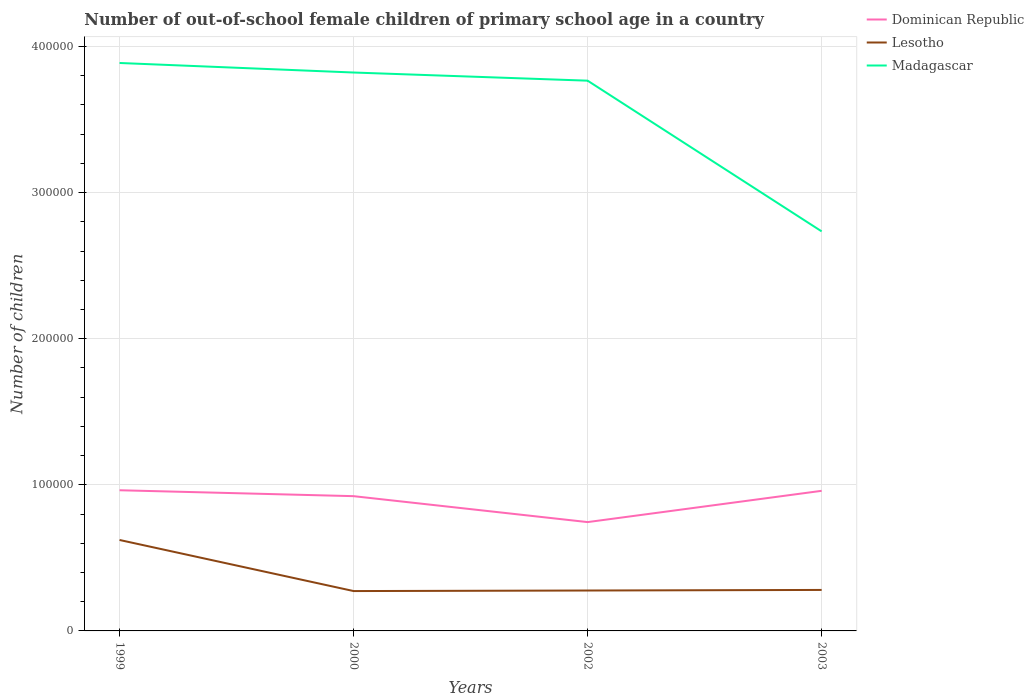Does the line corresponding to Madagascar intersect with the line corresponding to Dominican Republic?
Provide a succinct answer. No. Is the number of lines equal to the number of legend labels?
Provide a succinct answer. Yes. Across all years, what is the maximum number of out-of-school female children in Dominican Republic?
Ensure brevity in your answer.  7.45e+04. In which year was the number of out-of-school female children in Madagascar maximum?
Make the answer very short. 2003. What is the total number of out-of-school female children in Dominican Republic in the graph?
Ensure brevity in your answer.  1.78e+04. What is the difference between the highest and the second highest number of out-of-school female children in Madagascar?
Give a very brief answer. 1.15e+05. Is the number of out-of-school female children in Lesotho strictly greater than the number of out-of-school female children in Madagascar over the years?
Offer a terse response. Yes. How many years are there in the graph?
Your answer should be very brief. 4. What is the difference between two consecutive major ticks on the Y-axis?
Give a very brief answer. 1.00e+05. Are the values on the major ticks of Y-axis written in scientific E-notation?
Your answer should be very brief. No. How many legend labels are there?
Ensure brevity in your answer.  3. What is the title of the graph?
Give a very brief answer. Number of out-of-school female children of primary school age in a country. What is the label or title of the X-axis?
Provide a succinct answer. Years. What is the label or title of the Y-axis?
Keep it short and to the point. Number of children. What is the Number of children of Dominican Republic in 1999?
Provide a short and direct response. 9.63e+04. What is the Number of children in Lesotho in 1999?
Make the answer very short. 6.22e+04. What is the Number of children of Madagascar in 1999?
Ensure brevity in your answer.  3.89e+05. What is the Number of children in Dominican Republic in 2000?
Provide a short and direct response. 9.22e+04. What is the Number of children in Lesotho in 2000?
Your answer should be compact. 2.73e+04. What is the Number of children in Madagascar in 2000?
Give a very brief answer. 3.82e+05. What is the Number of children of Dominican Republic in 2002?
Offer a terse response. 7.45e+04. What is the Number of children of Lesotho in 2002?
Your answer should be very brief. 2.77e+04. What is the Number of children of Madagascar in 2002?
Your answer should be very brief. 3.77e+05. What is the Number of children of Dominican Republic in 2003?
Your answer should be very brief. 9.59e+04. What is the Number of children of Lesotho in 2003?
Keep it short and to the point. 2.81e+04. What is the Number of children of Madagascar in 2003?
Keep it short and to the point. 2.73e+05. Across all years, what is the maximum Number of children in Dominican Republic?
Offer a terse response. 9.63e+04. Across all years, what is the maximum Number of children in Lesotho?
Your answer should be compact. 6.22e+04. Across all years, what is the maximum Number of children of Madagascar?
Provide a short and direct response. 3.89e+05. Across all years, what is the minimum Number of children in Dominican Republic?
Give a very brief answer. 7.45e+04. Across all years, what is the minimum Number of children of Lesotho?
Offer a very short reply. 2.73e+04. Across all years, what is the minimum Number of children of Madagascar?
Offer a terse response. 2.73e+05. What is the total Number of children in Dominican Republic in the graph?
Keep it short and to the point. 3.59e+05. What is the total Number of children in Lesotho in the graph?
Provide a succinct answer. 1.45e+05. What is the total Number of children of Madagascar in the graph?
Your response must be concise. 1.42e+06. What is the difference between the Number of children in Dominican Republic in 1999 and that in 2000?
Keep it short and to the point. 4044. What is the difference between the Number of children in Lesotho in 1999 and that in 2000?
Offer a terse response. 3.50e+04. What is the difference between the Number of children of Madagascar in 1999 and that in 2000?
Offer a terse response. 6523. What is the difference between the Number of children in Dominican Republic in 1999 and that in 2002?
Make the answer very short. 2.18e+04. What is the difference between the Number of children of Lesotho in 1999 and that in 2002?
Keep it short and to the point. 3.46e+04. What is the difference between the Number of children of Madagascar in 1999 and that in 2002?
Make the answer very short. 1.21e+04. What is the difference between the Number of children in Dominican Republic in 1999 and that in 2003?
Ensure brevity in your answer.  392. What is the difference between the Number of children of Lesotho in 1999 and that in 2003?
Ensure brevity in your answer.  3.42e+04. What is the difference between the Number of children in Madagascar in 1999 and that in 2003?
Offer a very short reply. 1.15e+05. What is the difference between the Number of children in Dominican Republic in 2000 and that in 2002?
Offer a terse response. 1.78e+04. What is the difference between the Number of children in Lesotho in 2000 and that in 2002?
Your answer should be compact. -375. What is the difference between the Number of children in Madagascar in 2000 and that in 2002?
Keep it short and to the point. 5584. What is the difference between the Number of children of Dominican Republic in 2000 and that in 2003?
Provide a succinct answer. -3652. What is the difference between the Number of children of Lesotho in 2000 and that in 2003?
Your answer should be compact. -769. What is the difference between the Number of children in Madagascar in 2000 and that in 2003?
Provide a short and direct response. 1.09e+05. What is the difference between the Number of children in Dominican Republic in 2002 and that in 2003?
Provide a succinct answer. -2.14e+04. What is the difference between the Number of children in Lesotho in 2002 and that in 2003?
Your answer should be compact. -394. What is the difference between the Number of children in Madagascar in 2002 and that in 2003?
Your answer should be very brief. 1.03e+05. What is the difference between the Number of children in Dominican Republic in 1999 and the Number of children in Lesotho in 2000?
Your answer should be compact. 6.90e+04. What is the difference between the Number of children in Dominican Republic in 1999 and the Number of children in Madagascar in 2000?
Your answer should be compact. -2.86e+05. What is the difference between the Number of children in Lesotho in 1999 and the Number of children in Madagascar in 2000?
Your response must be concise. -3.20e+05. What is the difference between the Number of children in Dominican Republic in 1999 and the Number of children in Lesotho in 2002?
Provide a succinct answer. 6.86e+04. What is the difference between the Number of children of Dominican Republic in 1999 and the Number of children of Madagascar in 2002?
Provide a short and direct response. -2.80e+05. What is the difference between the Number of children of Lesotho in 1999 and the Number of children of Madagascar in 2002?
Your response must be concise. -3.14e+05. What is the difference between the Number of children of Dominican Republic in 1999 and the Number of children of Lesotho in 2003?
Provide a succinct answer. 6.82e+04. What is the difference between the Number of children of Dominican Republic in 1999 and the Number of children of Madagascar in 2003?
Offer a terse response. -1.77e+05. What is the difference between the Number of children in Lesotho in 1999 and the Number of children in Madagascar in 2003?
Your response must be concise. -2.11e+05. What is the difference between the Number of children in Dominican Republic in 2000 and the Number of children in Lesotho in 2002?
Your answer should be compact. 6.46e+04. What is the difference between the Number of children in Dominican Republic in 2000 and the Number of children in Madagascar in 2002?
Your response must be concise. -2.84e+05. What is the difference between the Number of children in Lesotho in 2000 and the Number of children in Madagascar in 2002?
Make the answer very short. -3.49e+05. What is the difference between the Number of children of Dominican Republic in 2000 and the Number of children of Lesotho in 2003?
Your answer should be very brief. 6.42e+04. What is the difference between the Number of children in Dominican Republic in 2000 and the Number of children in Madagascar in 2003?
Provide a succinct answer. -1.81e+05. What is the difference between the Number of children in Lesotho in 2000 and the Number of children in Madagascar in 2003?
Offer a terse response. -2.46e+05. What is the difference between the Number of children in Dominican Republic in 2002 and the Number of children in Lesotho in 2003?
Ensure brevity in your answer.  4.64e+04. What is the difference between the Number of children in Dominican Republic in 2002 and the Number of children in Madagascar in 2003?
Your answer should be very brief. -1.99e+05. What is the difference between the Number of children in Lesotho in 2002 and the Number of children in Madagascar in 2003?
Offer a terse response. -2.46e+05. What is the average Number of children of Dominican Republic per year?
Make the answer very short. 8.97e+04. What is the average Number of children in Lesotho per year?
Your answer should be compact. 3.63e+04. What is the average Number of children in Madagascar per year?
Offer a terse response. 3.55e+05. In the year 1999, what is the difference between the Number of children of Dominican Republic and Number of children of Lesotho?
Make the answer very short. 3.40e+04. In the year 1999, what is the difference between the Number of children of Dominican Republic and Number of children of Madagascar?
Offer a very short reply. -2.92e+05. In the year 1999, what is the difference between the Number of children of Lesotho and Number of children of Madagascar?
Provide a succinct answer. -3.26e+05. In the year 2000, what is the difference between the Number of children in Dominican Republic and Number of children in Lesotho?
Provide a succinct answer. 6.50e+04. In the year 2000, what is the difference between the Number of children in Dominican Republic and Number of children in Madagascar?
Offer a terse response. -2.90e+05. In the year 2000, what is the difference between the Number of children of Lesotho and Number of children of Madagascar?
Your response must be concise. -3.55e+05. In the year 2002, what is the difference between the Number of children of Dominican Republic and Number of children of Lesotho?
Make the answer very short. 4.68e+04. In the year 2002, what is the difference between the Number of children of Dominican Republic and Number of children of Madagascar?
Provide a short and direct response. -3.02e+05. In the year 2002, what is the difference between the Number of children of Lesotho and Number of children of Madagascar?
Provide a succinct answer. -3.49e+05. In the year 2003, what is the difference between the Number of children in Dominican Republic and Number of children in Lesotho?
Provide a succinct answer. 6.78e+04. In the year 2003, what is the difference between the Number of children in Dominican Republic and Number of children in Madagascar?
Your response must be concise. -1.78e+05. In the year 2003, what is the difference between the Number of children of Lesotho and Number of children of Madagascar?
Offer a very short reply. -2.45e+05. What is the ratio of the Number of children of Dominican Republic in 1999 to that in 2000?
Provide a succinct answer. 1.04. What is the ratio of the Number of children in Lesotho in 1999 to that in 2000?
Your response must be concise. 2.28. What is the ratio of the Number of children of Madagascar in 1999 to that in 2000?
Your response must be concise. 1.02. What is the ratio of the Number of children of Dominican Republic in 1999 to that in 2002?
Ensure brevity in your answer.  1.29. What is the ratio of the Number of children in Lesotho in 1999 to that in 2002?
Your answer should be very brief. 2.25. What is the ratio of the Number of children in Madagascar in 1999 to that in 2002?
Offer a very short reply. 1.03. What is the ratio of the Number of children in Dominican Republic in 1999 to that in 2003?
Offer a very short reply. 1. What is the ratio of the Number of children of Lesotho in 1999 to that in 2003?
Your answer should be very brief. 2.22. What is the ratio of the Number of children in Madagascar in 1999 to that in 2003?
Your answer should be very brief. 1.42. What is the ratio of the Number of children of Dominican Republic in 2000 to that in 2002?
Offer a terse response. 1.24. What is the ratio of the Number of children of Lesotho in 2000 to that in 2002?
Give a very brief answer. 0.99. What is the ratio of the Number of children of Madagascar in 2000 to that in 2002?
Ensure brevity in your answer.  1.01. What is the ratio of the Number of children in Dominican Republic in 2000 to that in 2003?
Your answer should be very brief. 0.96. What is the ratio of the Number of children in Lesotho in 2000 to that in 2003?
Your answer should be compact. 0.97. What is the ratio of the Number of children of Madagascar in 2000 to that in 2003?
Give a very brief answer. 1.4. What is the ratio of the Number of children of Dominican Republic in 2002 to that in 2003?
Offer a terse response. 0.78. What is the ratio of the Number of children of Lesotho in 2002 to that in 2003?
Your answer should be compact. 0.99. What is the ratio of the Number of children in Madagascar in 2002 to that in 2003?
Your answer should be very brief. 1.38. What is the difference between the highest and the second highest Number of children in Dominican Republic?
Make the answer very short. 392. What is the difference between the highest and the second highest Number of children of Lesotho?
Offer a terse response. 3.42e+04. What is the difference between the highest and the second highest Number of children in Madagascar?
Give a very brief answer. 6523. What is the difference between the highest and the lowest Number of children in Dominican Republic?
Provide a short and direct response. 2.18e+04. What is the difference between the highest and the lowest Number of children of Lesotho?
Offer a terse response. 3.50e+04. What is the difference between the highest and the lowest Number of children of Madagascar?
Give a very brief answer. 1.15e+05. 